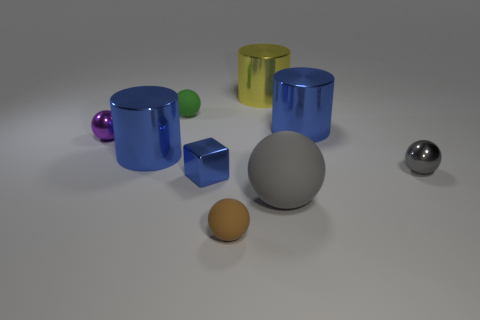What size is the gray shiny object that is in front of the big metallic cylinder that is on the left side of the green rubber sphere?
Offer a terse response. Small. What is the small brown thing that is in front of the green thing made of?
Provide a short and direct response. Rubber. What number of objects are gray objects that are left of the tiny gray thing or tiny things that are behind the small brown object?
Keep it short and to the point. 5. There is a large thing that is the same shape as the small purple metal object; what material is it?
Your answer should be very brief. Rubber. Do the large metal object to the left of the green matte thing and the shiny thing in front of the small gray metal thing have the same color?
Give a very brief answer. Yes. Are there any green objects that have the same size as the gray shiny object?
Offer a very short reply. Yes. There is a sphere that is both in front of the small gray shiny object and on the right side of the tiny brown object; what is its material?
Give a very brief answer. Rubber. How many shiny things are either gray spheres or blue things?
Offer a very short reply. 4. There is another big object that is the same material as the brown object; what is its shape?
Make the answer very short. Sphere. What number of shiny objects are in front of the tiny gray shiny object and behind the green rubber thing?
Give a very brief answer. 0. 